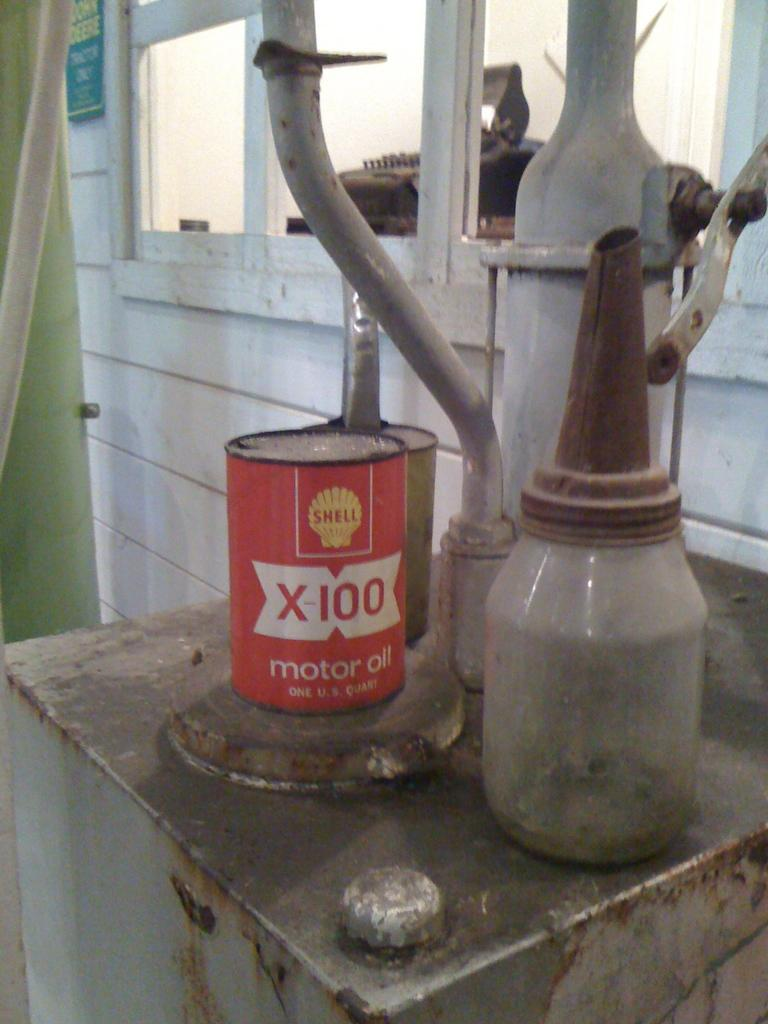<image>
Render a clear and concise summary of the photo. An old can of Shell X-100 motor oil is on an outdoor furnace. 